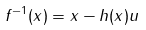Convert formula to latex. <formula><loc_0><loc_0><loc_500><loc_500>f ^ { - 1 } ( x ) = x - h ( x ) u</formula> 